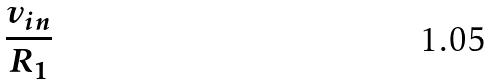<formula> <loc_0><loc_0><loc_500><loc_500>\frac { v _ { i n } } { R _ { 1 } }</formula> 